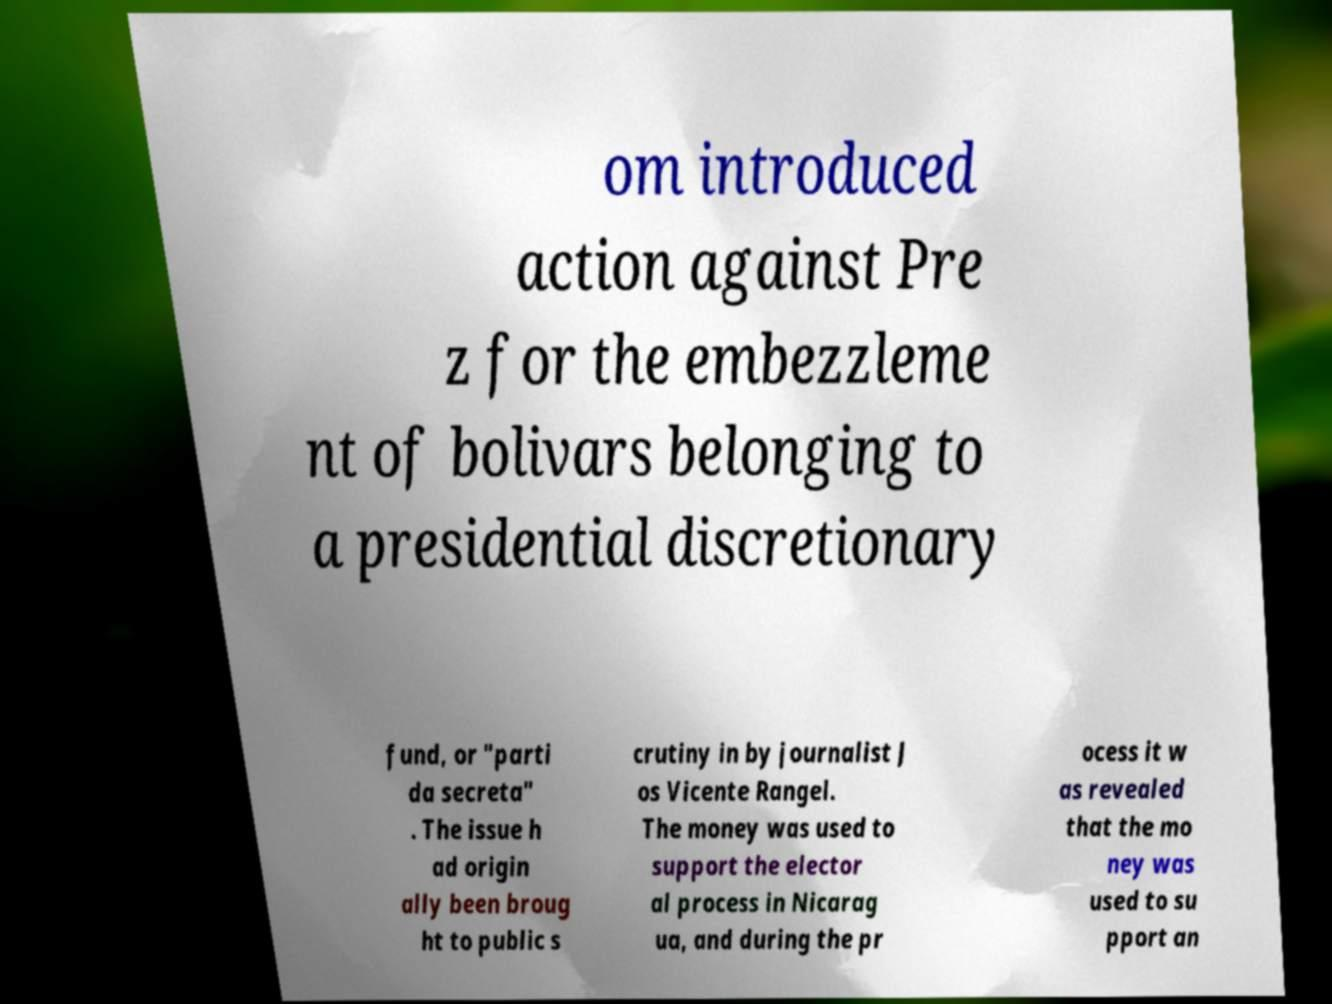Could you extract and type out the text from this image? om introduced action against Pre z for the embezzleme nt of bolivars belonging to a presidential discretionary fund, or "parti da secreta" . The issue h ad origin ally been broug ht to public s crutiny in by journalist J os Vicente Rangel. The money was used to support the elector al process in Nicarag ua, and during the pr ocess it w as revealed that the mo ney was used to su pport an 